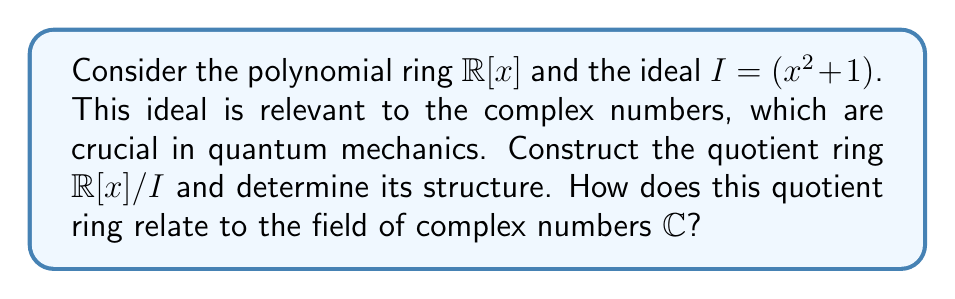Could you help me with this problem? 1) First, let's construct the quotient ring $\mathbb{R}[x]/I$:
   - Elements of this ring are cosets of the form $f(x) + I$, where $f(x) \in \mathbb{R}[x]$.
   - Two polynomials $f(x)$ and $g(x)$ are in the same coset if and only if $f(x) - g(x) \in I$.

2) The key observation is that in this quotient ring, $x^2 \equiv -1 \pmod{I}$, because $x^2 + 1 \in I$.

3) Any polynomial in $\mathbb{R}[x]$ can be written uniquely as $a + bx + (x^2 + 1)q(x)$, where $a, b \in \mathbb{R}$ and $q(x) \in \mathbb{R}[x]$.

4) In the quotient ring, $(x^2 + 1)q(x) \equiv 0 \pmod{I}$, so each element of $\mathbb{R}[x]/I$ can be uniquely represented as $a + bx$ where $a, b \in \mathbb{R}$.

5) The ring operations in $\mathbb{R}[x]/I$ are:
   - Addition: $(a_1 + b_1x) + (a_2 + b_2x) = (a_1 + a_2) + (b_1 + b_2)x$
   - Multiplication: $(a_1 + b_1x)(a_2 + b_2x) = (a_1a_2 - b_1b_2) + (a_1b_2 + b_1a_2)x$

6) This structure is isomorphic to the field of complex numbers $\mathbb{C}$:
   - The element $a + bx$ in $\mathbb{R}[x]/I$ corresponds to the complex number $a + bi$ in $\mathbb{C}$.
   - The isomorphism $\phi: \mathbb{R}[x]/I \to \mathbb{C}$ is given by $\phi(a + bx) = a + bi$.

7) This isomorphism preserves addition and multiplication, making $\mathbb{R}[x]/I$ a field.

Therefore, the quotient ring $\mathbb{R}[x]/I$ is isomorphic to the field of complex numbers $\mathbb{C}$.
Answer: $\mathbb{R}[x]/I \cong \mathbb{C}$ 